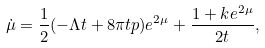<formula> <loc_0><loc_0><loc_500><loc_500>\dot { \mu } = \frac { 1 } { 2 } ( - \Lambda t + 8 \pi t p ) e ^ { 2 \mu } + \frac { 1 + k e ^ { 2 \mu } } { 2 t } ,</formula> 